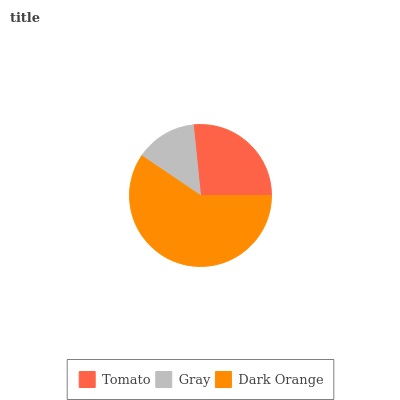Is Gray the minimum?
Answer yes or no. Yes. Is Dark Orange the maximum?
Answer yes or no. Yes. Is Dark Orange the minimum?
Answer yes or no. No. Is Gray the maximum?
Answer yes or no. No. Is Dark Orange greater than Gray?
Answer yes or no. Yes. Is Gray less than Dark Orange?
Answer yes or no. Yes. Is Gray greater than Dark Orange?
Answer yes or no. No. Is Dark Orange less than Gray?
Answer yes or no. No. Is Tomato the high median?
Answer yes or no. Yes. Is Tomato the low median?
Answer yes or no. Yes. Is Dark Orange the high median?
Answer yes or no. No. Is Gray the low median?
Answer yes or no. No. 